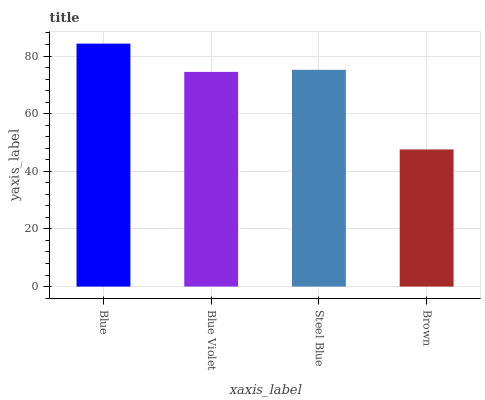Is Brown the minimum?
Answer yes or no. Yes. Is Blue the maximum?
Answer yes or no. Yes. Is Blue Violet the minimum?
Answer yes or no. No. Is Blue Violet the maximum?
Answer yes or no. No. Is Blue greater than Blue Violet?
Answer yes or no. Yes. Is Blue Violet less than Blue?
Answer yes or no. Yes. Is Blue Violet greater than Blue?
Answer yes or no. No. Is Blue less than Blue Violet?
Answer yes or no. No. Is Steel Blue the high median?
Answer yes or no. Yes. Is Blue Violet the low median?
Answer yes or no. Yes. Is Brown the high median?
Answer yes or no. No. Is Brown the low median?
Answer yes or no. No. 